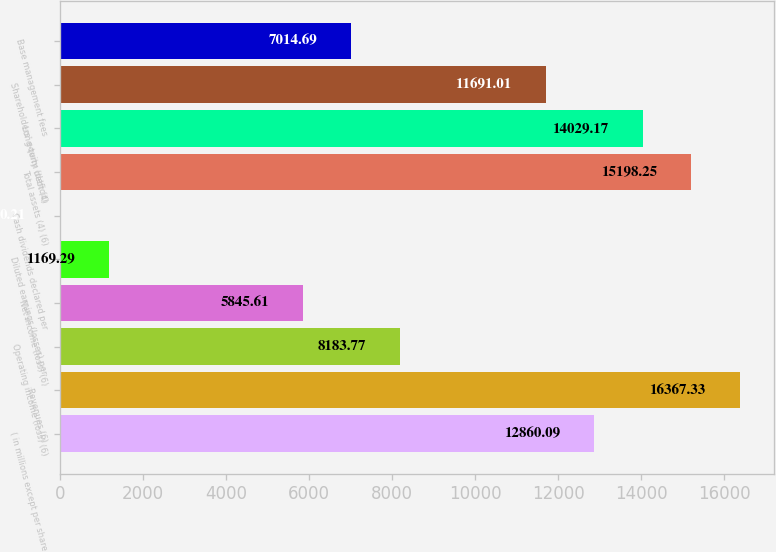Convert chart. <chart><loc_0><loc_0><loc_500><loc_500><bar_chart><fcel>( in millions except per share<fcel>Revenues (6)<fcel>Operating income (loss) (6)<fcel>Net income (loss) (6)<fcel>Diluted earnings (losses) per<fcel>Cash dividends declared per<fcel>Total assets (4) (6)<fcel>Long-term debt (4)<fcel>Shareholders' equity (deficit)<fcel>Base management fees<nl><fcel>12860.1<fcel>16367.3<fcel>8183.77<fcel>5845.61<fcel>1169.29<fcel>0.21<fcel>15198.2<fcel>14029.2<fcel>11691<fcel>7014.69<nl></chart> 